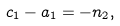Convert formula to latex. <formula><loc_0><loc_0><loc_500><loc_500>c _ { 1 } - a _ { 1 } = - n _ { 2 } ,</formula> 